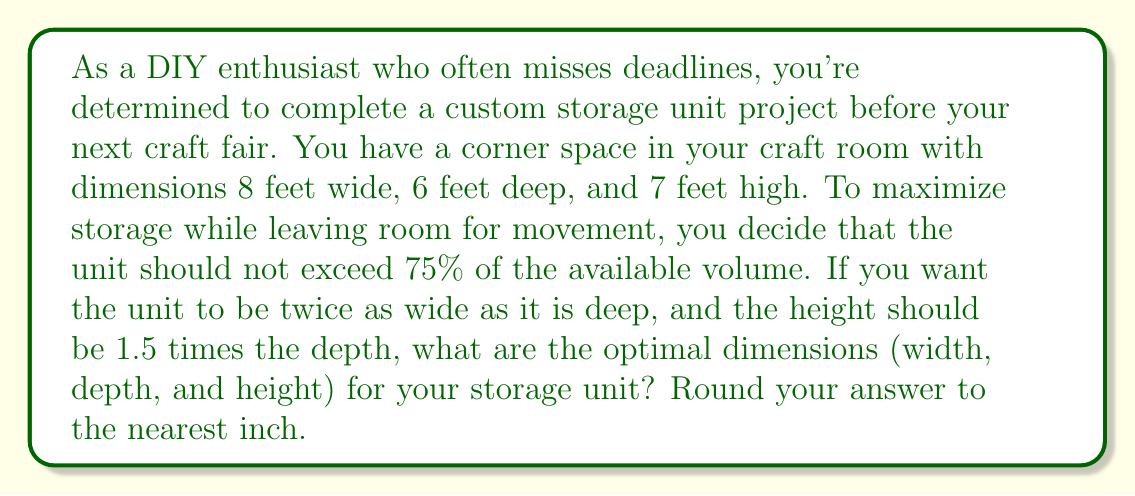Help me with this question. Let's approach this step-by-step:

1) First, let's define our variables:
   $w$ = width
   $d$ = depth
   $h$ = height

2) We're given these relationships:
   $w = 2d$
   $h = 1.5d$

3) The maximum volume of the storage unit should be 75% of the available space:
   $$(8 \times 6 \times 7) \times 0.75 = 252$$ cubic feet

4) The volume of our storage unit is:
   $$V = w \times d \times h$$

5) Substituting our relationships from step 2:
   $$V = (2d) \times d \times (1.5d) = 3d^3$$

6) This volume should be less than or equal to 252 cubic feet:
   $$3d^3 \leq 252$$

7) Solving for $d$:
   $$d^3 \leq 84$$
   $$d \leq \sqrt[3]{84} \approx 4.38$$

8) Since we need to round to the nearest inch and stay within the constraint, we'll use $d = 52$ inches (4 feet 4 inches).

9) Now we can calculate $w$ and $h$:
   $w = 2d = 2 \times 52 = 104$ inches (8 feet 8 inches)
   $h = 1.5d = 1.5 \times 52 = 78$ inches (6 feet 6 inches)

10) Let's verify that these dimensions fit within our space and volume constraints:
    Width: 104 inches < 8 feet (96 inches)
    Depth: 52 inches < 6 feet (72 inches)
    Height: 78 inches < 7 feet (84 inches)
    Volume: $104 \times 52 \times 78 = 422,656$ cubic inches $\approx 244.5$ cubic feet < 252 cubic feet

Therefore, the optimal dimensions that satisfy all constraints are 104 inches wide, 52 inches deep, and 78 inches high.
Answer: The optimal dimensions for the storage unit are:
Width: 104 inches (8 feet 8 inches)
Depth: 52 inches (4 feet 4 inches)
Height: 78 inches (6 feet 6 inches) 